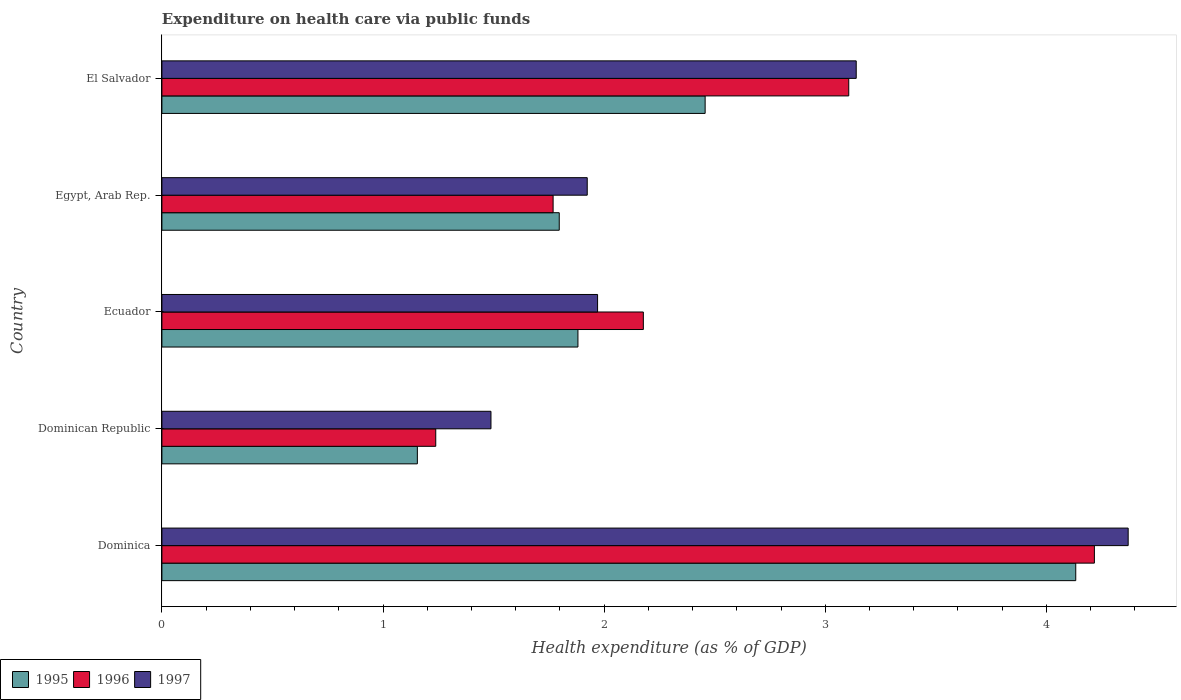How many different coloured bars are there?
Give a very brief answer. 3. What is the label of the 3rd group of bars from the top?
Your answer should be compact. Ecuador. In how many cases, is the number of bars for a given country not equal to the number of legend labels?
Offer a very short reply. 0. What is the expenditure made on health care in 1997 in Dominican Republic?
Your response must be concise. 1.49. Across all countries, what is the maximum expenditure made on health care in 1996?
Your answer should be very brief. 4.22. Across all countries, what is the minimum expenditure made on health care in 1996?
Provide a short and direct response. 1.24. In which country was the expenditure made on health care in 1995 maximum?
Your answer should be very brief. Dominica. In which country was the expenditure made on health care in 1997 minimum?
Your answer should be very brief. Dominican Republic. What is the total expenditure made on health care in 1997 in the graph?
Make the answer very short. 12.89. What is the difference between the expenditure made on health care in 1997 in Egypt, Arab Rep. and that in El Salvador?
Your answer should be very brief. -1.22. What is the difference between the expenditure made on health care in 1997 in Dominica and the expenditure made on health care in 1996 in Ecuador?
Offer a terse response. 2.19. What is the average expenditure made on health care in 1995 per country?
Keep it short and to the point. 2.28. What is the difference between the expenditure made on health care in 1996 and expenditure made on health care in 1997 in El Salvador?
Ensure brevity in your answer.  -0.03. In how many countries, is the expenditure made on health care in 1996 greater than 3 %?
Keep it short and to the point. 2. What is the ratio of the expenditure made on health care in 1996 in Egypt, Arab Rep. to that in El Salvador?
Your response must be concise. 0.57. Is the difference between the expenditure made on health care in 1996 in Egypt, Arab Rep. and El Salvador greater than the difference between the expenditure made on health care in 1997 in Egypt, Arab Rep. and El Salvador?
Ensure brevity in your answer.  No. What is the difference between the highest and the second highest expenditure made on health care in 1995?
Your answer should be compact. 1.68. What is the difference between the highest and the lowest expenditure made on health care in 1996?
Your answer should be compact. 2.98. In how many countries, is the expenditure made on health care in 1997 greater than the average expenditure made on health care in 1997 taken over all countries?
Your answer should be compact. 2. What does the 3rd bar from the top in Dominica represents?
Your answer should be very brief. 1995. What does the 3rd bar from the bottom in Egypt, Arab Rep. represents?
Give a very brief answer. 1997. Is it the case that in every country, the sum of the expenditure made on health care in 1996 and expenditure made on health care in 1995 is greater than the expenditure made on health care in 1997?
Give a very brief answer. Yes. What is the difference between two consecutive major ticks on the X-axis?
Your answer should be very brief. 1. Are the values on the major ticks of X-axis written in scientific E-notation?
Your response must be concise. No. How many legend labels are there?
Ensure brevity in your answer.  3. What is the title of the graph?
Provide a succinct answer. Expenditure on health care via public funds. Does "2011" appear as one of the legend labels in the graph?
Ensure brevity in your answer.  No. What is the label or title of the X-axis?
Give a very brief answer. Health expenditure (as % of GDP). What is the Health expenditure (as % of GDP) of 1995 in Dominica?
Provide a short and direct response. 4.13. What is the Health expenditure (as % of GDP) in 1996 in Dominica?
Your answer should be very brief. 4.22. What is the Health expenditure (as % of GDP) of 1997 in Dominica?
Offer a terse response. 4.37. What is the Health expenditure (as % of GDP) in 1995 in Dominican Republic?
Keep it short and to the point. 1.16. What is the Health expenditure (as % of GDP) in 1996 in Dominican Republic?
Provide a short and direct response. 1.24. What is the Health expenditure (as % of GDP) of 1997 in Dominican Republic?
Your answer should be compact. 1.49. What is the Health expenditure (as % of GDP) of 1995 in Ecuador?
Ensure brevity in your answer.  1.88. What is the Health expenditure (as % of GDP) of 1996 in Ecuador?
Offer a terse response. 2.18. What is the Health expenditure (as % of GDP) in 1997 in Ecuador?
Offer a terse response. 1.97. What is the Health expenditure (as % of GDP) in 1995 in Egypt, Arab Rep.?
Your answer should be very brief. 1.8. What is the Health expenditure (as % of GDP) in 1996 in Egypt, Arab Rep.?
Offer a very short reply. 1.77. What is the Health expenditure (as % of GDP) in 1997 in Egypt, Arab Rep.?
Provide a short and direct response. 1.92. What is the Health expenditure (as % of GDP) in 1995 in El Salvador?
Provide a succinct answer. 2.46. What is the Health expenditure (as % of GDP) of 1996 in El Salvador?
Your answer should be very brief. 3.11. What is the Health expenditure (as % of GDP) in 1997 in El Salvador?
Your answer should be compact. 3.14. Across all countries, what is the maximum Health expenditure (as % of GDP) in 1995?
Offer a terse response. 4.13. Across all countries, what is the maximum Health expenditure (as % of GDP) of 1996?
Offer a very short reply. 4.22. Across all countries, what is the maximum Health expenditure (as % of GDP) of 1997?
Ensure brevity in your answer.  4.37. Across all countries, what is the minimum Health expenditure (as % of GDP) in 1995?
Provide a succinct answer. 1.16. Across all countries, what is the minimum Health expenditure (as % of GDP) in 1996?
Offer a terse response. 1.24. Across all countries, what is the minimum Health expenditure (as % of GDP) of 1997?
Offer a terse response. 1.49. What is the total Health expenditure (as % of GDP) in 1995 in the graph?
Keep it short and to the point. 11.42. What is the total Health expenditure (as % of GDP) in 1996 in the graph?
Provide a short and direct response. 12.51. What is the total Health expenditure (as % of GDP) of 1997 in the graph?
Make the answer very short. 12.89. What is the difference between the Health expenditure (as % of GDP) in 1995 in Dominica and that in Dominican Republic?
Give a very brief answer. 2.98. What is the difference between the Health expenditure (as % of GDP) in 1996 in Dominica and that in Dominican Republic?
Keep it short and to the point. 2.98. What is the difference between the Health expenditure (as % of GDP) of 1997 in Dominica and that in Dominican Republic?
Offer a terse response. 2.88. What is the difference between the Health expenditure (as % of GDP) of 1995 in Dominica and that in Ecuador?
Your answer should be very brief. 2.25. What is the difference between the Health expenditure (as % of GDP) in 1996 in Dominica and that in Ecuador?
Ensure brevity in your answer.  2.04. What is the difference between the Health expenditure (as % of GDP) of 1997 in Dominica and that in Ecuador?
Ensure brevity in your answer.  2.4. What is the difference between the Health expenditure (as % of GDP) in 1995 in Dominica and that in Egypt, Arab Rep.?
Your response must be concise. 2.34. What is the difference between the Health expenditure (as % of GDP) of 1996 in Dominica and that in Egypt, Arab Rep.?
Your response must be concise. 2.45. What is the difference between the Health expenditure (as % of GDP) in 1997 in Dominica and that in Egypt, Arab Rep.?
Your response must be concise. 2.45. What is the difference between the Health expenditure (as % of GDP) in 1995 in Dominica and that in El Salvador?
Your response must be concise. 1.68. What is the difference between the Health expenditure (as % of GDP) in 1996 in Dominica and that in El Salvador?
Offer a terse response. 1.11. What is the difference between the Health expenditure (as % of GDP) in 1997 in Dominica and that in El Salvador?
Keep it short and to the point. 1.23. What is the difference between the Health expenditure (as % of GDP) of 1995 in Dominican Republic and that in Ecuador?
Your answer should be very brief. -0.73. What is the difference between the Health expenditure (as % of GDP) of 1996 in Dominican Republic and that in Ecuador?
Keep it short and to the point. -0.94. What is the difference between the Health expenditure (as % of GDP) in 1997 in Dominican Republic and that in Ecuador?
Ensure brevity in your answer.  -0.48. What is the difference between the Health expenditure (as % of GDP) in 1995 in Dominican Republic and that in Egypt, Arab Rep.?
Ensure brevity in your answer.  -0.64. What is the difference between the Health expenditure (as % of GDP) in 1996 in Dominican Republic and that in Egypt, Arab Rep.?
Your answer should be very brief. -0.53. What is the difference between the Health expenditure (as % of GDP) in 1997 in Dominican Republic and that in Egypt, Arab Rep.?
Your answer should be very brief. -0.44. What is the difference between the Health expenditure (as % of GDP) in 1995 in Dominican Republic and that in El Salvador?
Keep it short and to the point. -1.3. What is the difference between the Health expenditure (as % of GDP) of 1996 in Dominican Republic and that in El Salvador?
Provide a succinct answer. -1.87. What is the difference between the Health expenditure (as % of GDP) of 1997 in Dominican Republic and that in El Salvador?
Make the answer very short. -1.65. What is the difference between the Health expenditure (as % of GDP) in 1995 in Ecuador and that in Egypt, Arab Rep.?
Give a very brief answer. 0.08. What is the difference between the Health expenditure (as % of GDP) in 1996 in Ecuador and that in Egypt, Arab Rep.?
Keep it short and to the point. 0.41. What is the difference between the Health expenditure (as % of GDP) of 1997 in Ecuador and that in Egypt, Arab Rep.?
Offer a terse response. 0.05. What is the difference between the Health expenditure (as % of GDP) in 1995 in Ecuador and that in El Salvador?
Your answer should be compact. -0.58. What is the difference between the Health expenditure (as % of GDP) in 1996 in Ecuador and that in El Salvador?
Offer a terse response. -0.93. What is the difference between the Health expenditure (as % of GDP) in 1997 in Ecuador and that in El Salvador?
Your answer should be compact. -1.17. What is the difference between the Health expenditure (as % of GDP) in 1995 in Egypt, Arab Rep. and that in El Salvador?
Offer a very short reply. -0.66. What is the difference between the Health expenditure (as % of GDP) of 1996 in Egypt, Arab Rep. and that in El Salvador?
Make the answer very short. -1.34. What is the difference between the Health expenditure (as % of GDP) in 1997 in Egypt, Arab Rep. and that in El Salvador?
Make the answer very short. -1.22. What is the difference between the Health expenditure (as % of GDP) of 1995 in Dominica and the Health expenditure (as % of GDP) of 1996 in Dominican Republic?
Ensure brevity in your answer.  2.89. What is the difference between the Health expenditure (as % of GDP) of 1995 in Dominica and the Health expenditure (as % of GDP) of 1997 in Dominican Republic?
Ensure brevity in your answer.  2.64. What is the difference between the Health expenditure (as % of GDP) in 1996 in Dominica and the Health expenditure (as % of GDP) in 1997 in Dominican Republic?
Your answer should be compact. 2.73. What is the difference between the Health expenditure (as % of GDP) of 1995 in Dominica and the Health expenditure (as % of GDP) of 1996 in Ecuador?
Make the answer very short. 1.96. What is the difference between the Health expenditure (as % of GDP) in 1995 in Dominica and the Health expenditure (as % of GDP) in 1997 in Ecuador?
Keep it short and to the point. 2.16. What is the difference between the Health expenditure (as % of GDP) in 1996 in Dominica and the Health expenditure (as % of GDP) in 1997 in Ecuador?
Your answer should be very brief. 2.25. What is the difference between the Health expenditure (as % of GDP) in 1995 in Dominica and the Health expenditure (as % of GDP) in 1996 in Egypt, Arab Rep.?
Ensure brevity in your answer.  2.36. What is the difference between the Health expenditure (as % of GDP) in 1995 in Dominica and the Health expenditure (as % of GDP) in 1997 in Egypt, Arab Rep.?
Keep it short and to the point. 2.21. What is the difference between the Health expenditure (as % of GDP) of 1996 in Dominica and the Health expenditure (as % of GDP) of 1997 in Egypt, Arab Rep.?
Your response must be concise. 2.29. What is the difference between the Health expenditure (as % of GDP) in 1995 in Dominica and the Health expenditure (as % of GDP) in 1996 in El Salvador?
Provide a succinct answer. 1.03. What is the difference between the Health expenditure (as % of GDP) of 1995 in Dominica and the Health expenditure (as % of GDP) of 1997 in El Salvador?
Your response must be concise. 0.99. What is the difference between the Health expenditure (as % of GDP) of 1996 in Dominica and the Health expenditure (as % of GDP) of 1997 in El Salvador?
Make the answer very short. 1.08. What is the difference between the Health expenditure (as % of GDP) in 1995 in Dominican Republic and the Health expenditure (as % of GDP) in 1996 in Ecuador?
Offer a terse response. -1.02. What is the difference between the Health expenditure (as % of GDP) of 1995 in Dominican Republic and the Health expenditure (as % of GDP) of 1997 in Ecuador?
Offer a terse response. -0.82. What is the difference between the Health expenditure (as % of GDP) in 1996 in Dominican Republic and the Health expenditure (as % of GDP) in 1997 in Ecuador?
Offer a very short reply. -0.73. What is the difference between the Health expenditure (as % of GDP) of 1995 in Dominican Republic and the Health expenditure (as % of GDP) of 1996 in Egypt, Arab Rep.?
Provide a succinct answer. -0.61. What is the difference between the Health expenditure (as % of GDP) of 1995 in Dominican Republic and the Health expenditure (as % of GDP) of 1997 in Egypt, Arab Rep.?
Ensure brevity in your answer.  -0.77. What is the difference between the Health expenditure (as % of GDP) in 1996 in Dominican Republic and the Health expenditure (as % of GDP) in 1997 in Egypt, Arab Rep.?
Ensure brevity in your answer.  -0.69. What is the difference between the Health expenditure (as % of GDP) of 1995 in Dominican Republic and the Health expenditure (as % of GDP) of 1996 in El Salvador?
Offer a terse response. -1.95. What is the difference between the Health expenditure (as % of GDP) of 1995 in Dominican Republic and the Health expenditure (as % of GDP) of 1997 in El Salvador?
Your response must be concise. -1.98. What is the difference between the Health expenditure (as % of GDP) in 1996 in Dominican Republic and the Health expenditure (as % of GDP) in 1997 in El Salvador?
Make the answer very short. -1.9. What is the difference between the Health expenditure (as % of GDP) of 1995 in Ecuador and the Health expenditure (as % of GDP) of 1996 in Egypt, Arab Rep.?
Ensure brevity in your answer.  0.11. What is the difference between the Health expenditure (as % of GDP) in 1995 in Ecuador and the Health expenditure (as % of GDP) in 1997 in Egypt, Arab Rep.?
Make the answer very short. -0.04. What is the difference between the Health expenditure (as % of GDP) in 1996 in Ecuador and the Health expenditure (as % of GDP) in 1997 in Egypt, Arab Rep.?
Provide a succinct answer. 0.25. What is the difference between the Health expenditure (as % of GDP) of 1995 in Ecuador and the Health expenditure (as % of GDP) of 1996 in El Salvador?
Make the answer very short. -1.22. What is the difference between the Health expenditure (as % of GDP) of 1995 in Ecuador and the Health expenditure (as % of GDP) of 1997 in El Salvador?
Ensure brevity in your answer.  -1.26. What is the difference between the Health expenditure (as % of GDP) in 1996 in Ecuador and the Health expenditure (as % of GDP) in 1997 in El Salvador?
Keep it short and to the point. -0.96. What is the difference between the Health expenditure (as % of GDP) in 1995 in Egypt, Arab Rep. and the Health expenditure (as % of GDP) in 1996 in El Salvador?
Your response must be concise. -1.31. What is the difference between the Health expenditure (as % of GDP) in 1995 in Egypt, Arab Rep. and the Health expenditure (as % of GDP) in 1997 in El Salvador?
Keep it short and to the point. -1.34. What is the difference between the Health expenditure (as % of GDP) of 1996 in Egypt, Arab Rep. and the Health expenditure (as % of GDP) of 1997 in El Salvador?
Keep it short and to the point. -1.37. What is the average Health expenditure (as % of GDP) of 1995 per country?
Offer a very short reply. 2.28. What is the average Health expenditure (as % of GDP) of 1996 per country?
Give a very brief answer. 2.5. What is the average Health expenditure (as % of GDP) in 1997 per country?
Ensure brevity in your answer.  2.58. What is the difference between the Health expenditure (as % of GDP) of 1995 and Health expenditure (as % of GDP) of 1996 in Dominica?
Ensure brevity in your answer.  -0.08. What is the difference between the Health expenditure (as % of GDP) in 1995 and Health expenditure (as % of GDP) in 1997 in Dominica?
Keep it short and to the point. -0.24. What is the difference between the Health expenditure (as % of GDP) in 1996 and Health expenditure (as % of GDP) in 1997 in Dominica?
Offer a very short reply. -0.15. What is the difference between the Health expenditure (as % of GDP) of 1995 and Health expenditure (as % of GDP) of 1996 in Dominican Republic?
Your answer should be compact. -0.08. What is the difference between the Health expenditure (as % of GDP) of 1995 and Health expenditure (as % of GDP) of 1997 in Dominican Republic?
Your answer should be compact. -0.33. What is the difference between the Health expenditure (as % of GDP) in 1996 and Health expenditure (as % of GDP) in 1997 in Dominican Republic?
Your answer should be very brief. -0.25. What is the difference between the Health expenditure (as % of GDP) in 1995 and Health expenditure (as % of GDP) in 1996 in Ecuador?
Offer a very short reply. -0.3. What is the difference between the Health expenditure (as % of GDP) of 1995 and Health expenditure (as % of GDP) of 1997 in Ecuador?
Provide a succinct answer. -0.09. What is the difference between the Health expenditure (as % of GDP) of 1996 and Health expenditure (as % of GDP) of 1997 in Ecuador?
Keep it short and to the point. 0.21. What is the difference between the Health expenditure (as % of GDP) in 1995 and Health expenditure (as % of GDP) in 1996 in Egypt, Arab Rep.?
Offer a very short reply. 0.03. What is the difference between the Health expenditure (as % of GDP) of 1995 and Health expenditure (as % of GDP) of 1997 in Egypt, Arab Rep.?
Your answer should be compact. -0.13. What is the difference between the Health expenditure (as % of GDP) in 1996 and Health expenditure (as % of GDP) in 1997 in Egypt, Arab Rep.?
Ensure brevity in your answer.  -0.15. What is the difference between the Health expenditure (as % of GDP) in 1995 and Health expenditure (as % of GDP) in 1996 in El Salvador?
Offer a very short reply. -0.65. What is the difference between the Health expenditure (as % of GDP) of 1995 and Health expenditure (as % of GDP) of 1997 in El Salvador?
Ensure brevity in your answer.  -0.68. What is the difference between the Health expenditure (as % of GDP) in 1996 and Health expenditure (as % of GDP) in 1997 in El Salvador?
Provide a short and direct response. -0.03. What is the ratio of the Health expenditure (as % of GDP) in 1995 in Dominica to that in Dominican Republic?
Provide a short and direct response. 3.58. What is the ratio of the Health expenditure (as % of GDP) of 1996 in Dominica to that in Dominican Republic?
Provide a short and direct response. 3.41. What is the ratio of the Health expenditure (as % of GDP) of 1997 in Dominica to that in Dominican Republic?
Your answer should be very brief. 2.94. What is the ratio of the Health expenditure (as % of GDP) in 1995 in Dominica to that in Ecuador?
Your response must be concise. 2.2. What is the ratio of the Health expenditure (as % of GDP) of 1996 in Dominica to that in Ecuador?
Your answer should be very brief. 1.94. What is the ratio of the Health expenditure (as % of GDP) of 1997 in Dominica to that in Ecuador?
Offer a very short reply. 2.22. What is the ratio of the Health expenditure (as % of GDP) of 1995 in Dominica to that in Egypt, Arab Rep.?
Your answer should be very brief. 2.3. What is the ratio of the Health expenditure (as % of GDP) in 1996 in Dominica to that in Egypt, Arab Rep.?
Keep it short and to the point. 2.38. What is the ratio of the Health expenditure (as % of GDP) in 1997 in Dominica to that in Egypt, Arab Rep.?
Make the answer very short. 2.27. What is the ratio of the Health expenditure (as % of GDP) of 1995 in Dominica to that in El Salvador?
Offer a very short reply. 1.68. What is the ratio of the Health expenditure (as % of GDP) of 1996 in Dominica to that in El Salvador?
Ensure brevity in your answer.  1.36. What is the ratio of the Health expenditure (as % of GDP) of 1997 in Dominica to that in El Salvador?
Make the answer very short. 1.39. What is the ratio of the Health expenditure (as % of GDP) in 1995 in Dominican Republic to that in Ecuador?
Provide a short and direct response. 0.61. What is the ratio of the Health expenditure (as % of GDP) in 1996 in Dominican Republic to that in Ecuador?
Offer a terse response. 0.57. What is the ratio of the Health expenditure (as % of GDP) in 1997 in Dominican Republic to that in Ecuador?
Give a very brief answer. 0.76. What is the ratio of the Health expenditure (as % of GDP) of 1995 in Dominican Republic to that in Egypt, Arab Rep.?
Offer a terse response. 0.64. What is the ratio of the Health expenditure (as % of GDP) in 1996 in Dominican Republic to that in Egypt, Arab Rep.?
Offer a terse response. 0.7. What is the ratio of the Health expenditure (as % of GDP) of 1997 in Dominican Republic to that in Egypt, Arab Rep.?
Your answer should be very brief. 0.77. What is the ratio of the Health expenditure (as % of GDP) of 1995 in Dominican Republic to that in El Salvador?
Provide a succinct answer. 0.47. What is the ratio of the Health expenditure (as % of GDP) of 1996 in Dominican Republic to that in El Salvador?
Provide a succinct answer. 0.4. What is the ratio of the Health expenditure (as % of GDP) of 1997 in Dominican Republic to that in El Salvador?
Make the answer very short. 0.47. What is the ratio of the Health expenditure (as % of GDP) in 1995 in Ecuador to that in Egypt, Arab Rep.?
Make the answer very short. 1.05. What is the ratio of the Health expenditure (as % of GDP) in 1996 in Ecuador to that in Egypt, Arab Rep.?
Provide a short and direct response. 1.23. What is the ratio of the Health expenditure (as % of GDP) of 1997 in Ecuador to that in Egypt, Arab Rep.?
Provide a succinct answer. 1.02. What is the ratio of the Health expenditure (as % of GDP) in 1995 in Ecuador to that in El Salvador?
Ensure brevity in your answer.  0.77. What is the ratio of the Health expenditure (as % of GDP) in 1996 in Ecuador to that in El Salvador?
Ensure brevity in your answer.  0.7. What is the ratio of the Health expenditure (as % of GDP) of 1997 in Ecuador to that in El Salvador?
Keep it short and to the point. 0.63. What is the ratio of the Health expenditure (as % of GDP) in 1995 in Egypt, Arab Rep. to that in El Salvador?
Give a very brief answer. 0.73. What is the ratio of the Health expenditure (as % of GDP) of 1996 in Egypt, Arab Rep. to that in El Salvador?
Offer a terse response. 0.57. What is the ratio of the Health expenditure (as % of GDP) of 1997 in Egypt, Arab Rep. to that in El Salvador?
Your response must be concise. 0.61. What is the difference between the highest and the second highest Health expenditure (as % of GDP) of 1995?
Give a very brief answer. 1.68. What is the difference between the highest and the second highest Health expenditure (as % of GDP) in 1996?
Your answer should be compact. 1.11. What is the difference between the highest and the second highest Health expenditure (as % of GDP) of 1997?
Your response must be concise. 1.23. What is the difference between the highest and the lowest Health expenditure (as % of GDP) in 1995?
Your answer should be very brief. 2.98. What is the difference between the highest and the lowest Health expenditure (as % of GDP) in 1996?
Your answer should be very brief. 2.98. What is the difference between the highest and the lowest Health expenditure (as % of GDP) of 1997?
Offer a terse response. 2.88. 